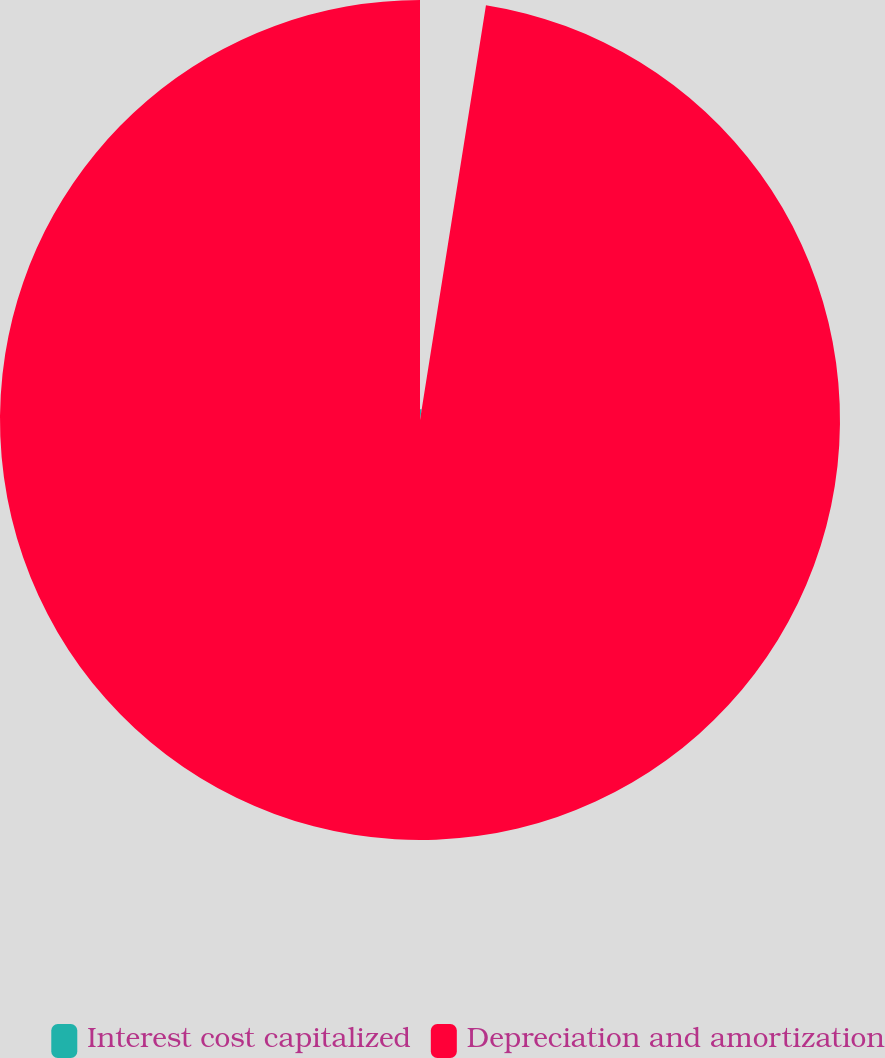<chart> <loc_0><loc_0><loc_500><loc_500><pie_chart><fcel>Interest cost capitalized<fcel>Depreciation and amortization<nl><fcel>2.51%<fcel>97.49%<nl></chart> 